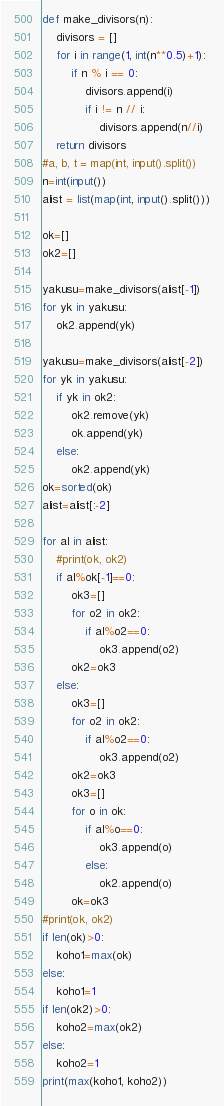<code> <loc_0><loc_0><loc_500><loc_500><_Python_>def make_divisors(n):
    divisors = []
    for i in range(1, int(n**0.5)+1):
        if n % i == 0:
            divisors.append(i)
            if i != n // i:
                divisors.append(n//i)
    return divisors
#a, b, t = map(int, input().split())
n=int(input())
alist = list(map(int, input().split()))

ok=[]
ok2=[]

yakusu=make_divisors(alist[-1])
for yk in yakusu:
    ok2.append(yk)

yakusu=make_divisors(alist[-2])
for yk in yakusu:
    if yk in ok2:
        ok2.remove(yk)
        ok.append(yk)
    else:
        ok2.append(yk)
ok=sorted(ok)
alist=alist[:-2]

for al in alist:
    #print(ok, ok2)
    if al%ok[-1]==0:
        ok3=[]
        for o2 in ok2:
            if al%o2==0:
                ok3.append(o2)
        ok2=ok3
    else:
        ok3=[]
        for o2 in ok2:
            if al%o2==0:
                ok3.append(o2)
        ok2=ok3
        ok3=[]
        for o in ok:
            if al%o==0:
                ok3.append(o)
            else:
                ok2.append(o)
        ok=ok3
#print(ok, ok2)
if len(ok)>0:
    koho1=max(ok)
else:
    koho1=1
if len(ok2)>0:
    koho2=max(ok2)
else:
    koho2=1
print(max(koho1, koho2))</code> 